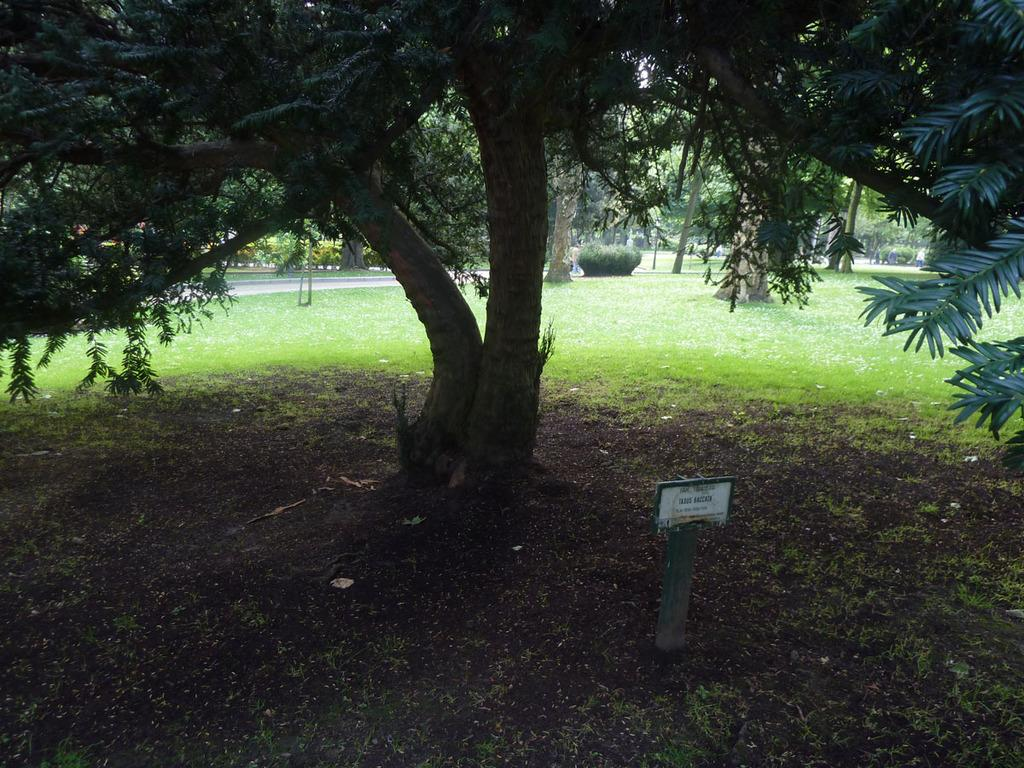What is attached to the pole in the image? There is a board attached to the pole in the image. What can be seen behind the board? There are trees behind the board. What type of ground is visible in the image? There is grass visible in the image. What type of vegetation is present in the image? There are plants in the image. How many patches are on the pig in the image? There is no pig present in the image, so there are no patches to count. 